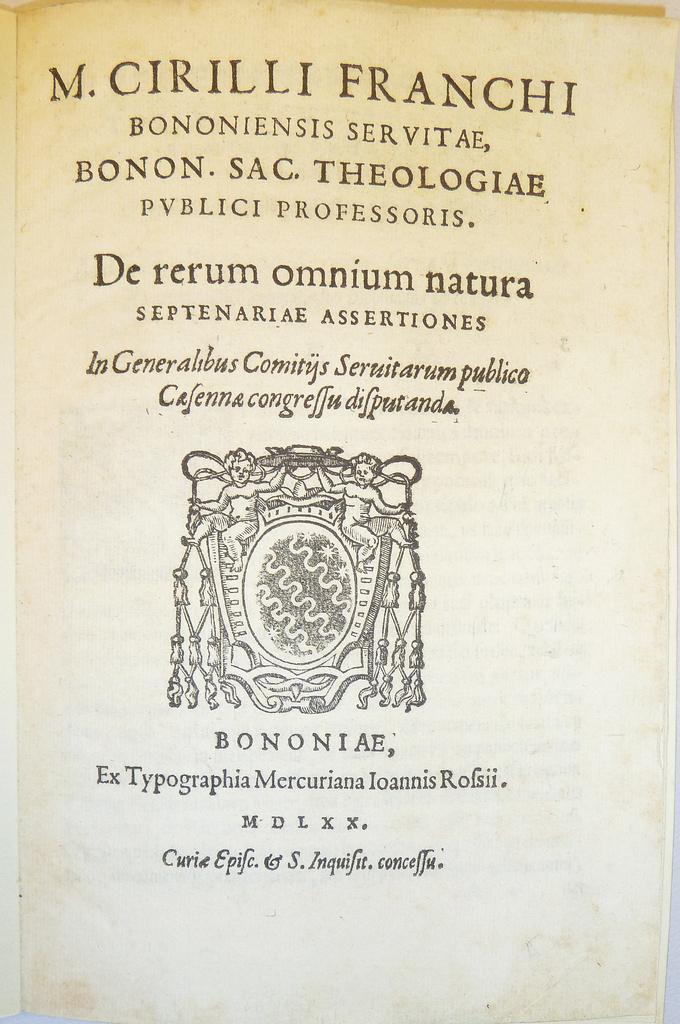What roman numeral is listed above the bottom line of text?
Offer a terse response. Mdlxx. 